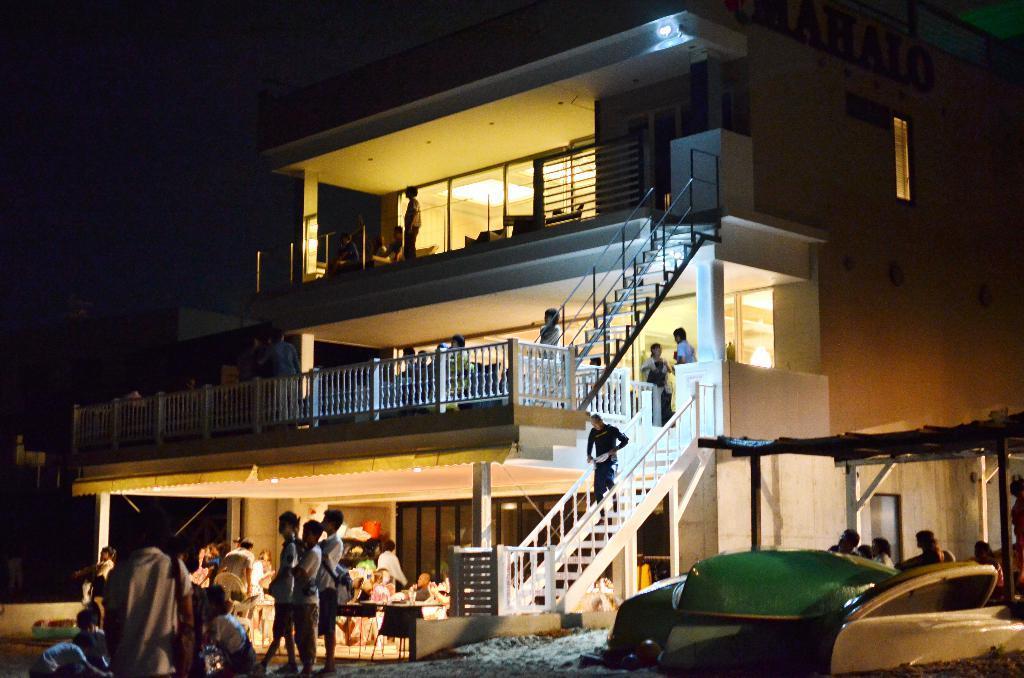Could you give a brief overview of what you see in this image? In the foreground of this image, there is a building where few persons are present in it. In front, there are three men standing on the ground. On right, there are few persons under a shed. 